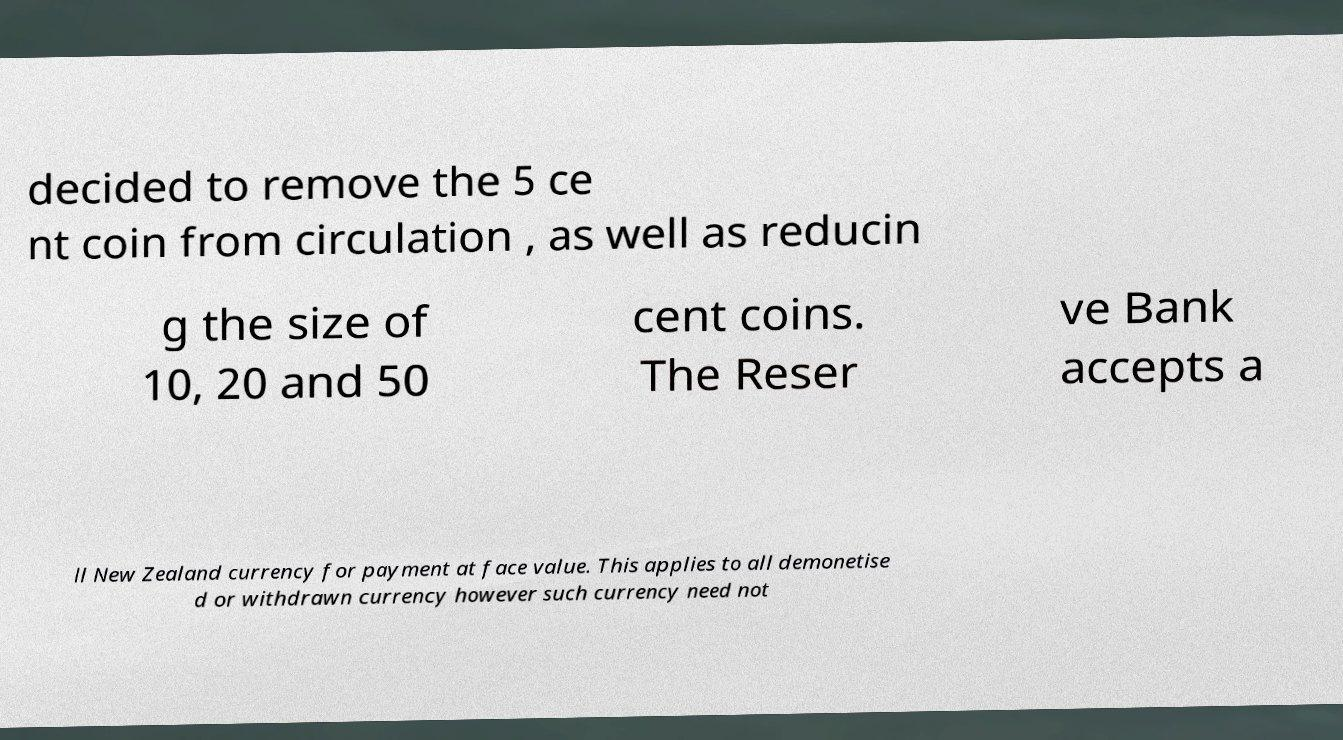Could you assist in decoding the text presented in this image and type it out clearly? decided to remove the 5 ce nt coin from circulation , as well as reducin g the size of 10, 20 and 50 cent coins. The Reser ve Bank accepts a ll New Zealand currency for payment at face value. This applies to all demonetise d or withdrawn currency however such currency need not 